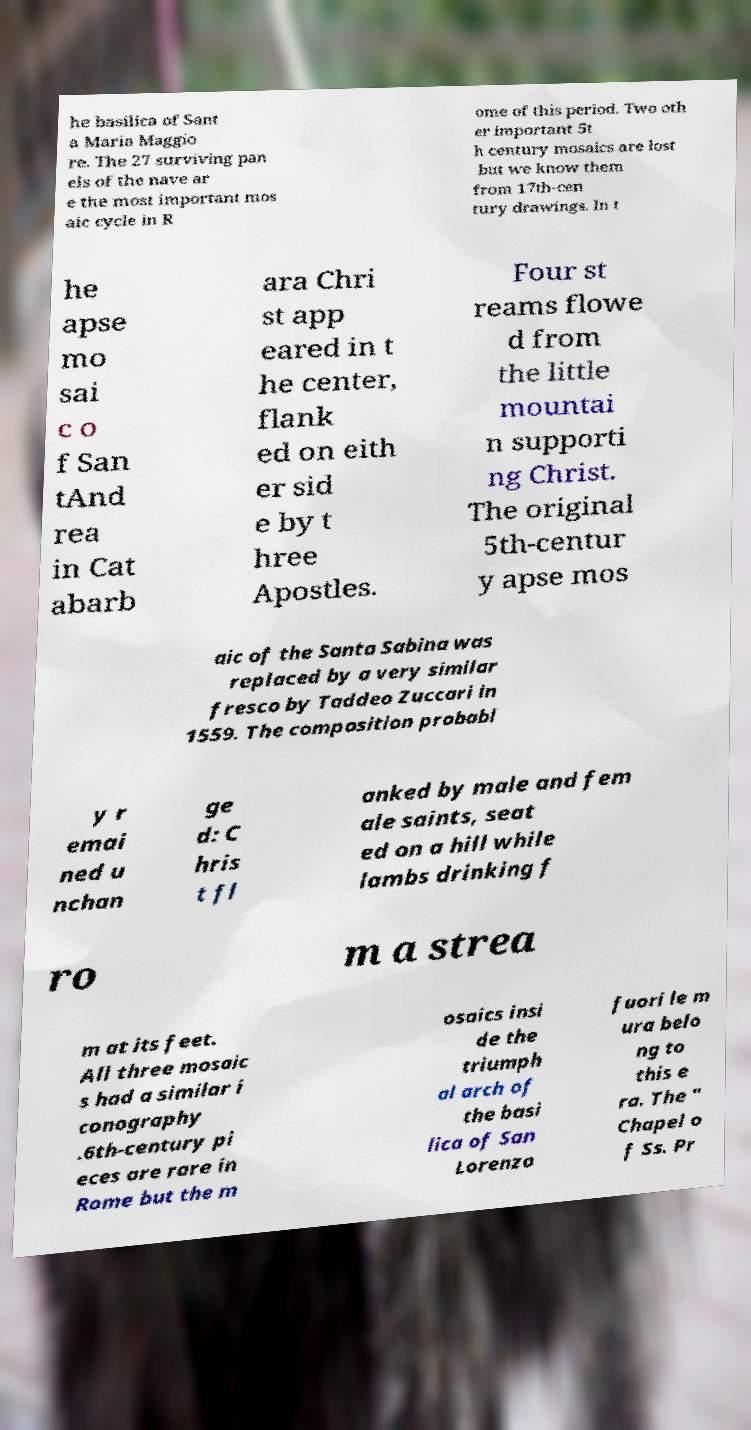Please read and relay the text visible in this image. What does it say? he basilica of Sant a Maria Maggio re. The 27 surviving pan els of the nave ar e the most important mos aic cycle in R ome of this period. Two oth er important 5t h century mosaics are lost but we know them from 17th-cen tury drawings. In t he apse mo sai c o f San tAnd rea in Cat abarb ara Chri st app eared in t he center, flank ed on eith er sid e by t hree Apostles. Four st reams flowe d from the little mountai n supporti ng Christ. The original 5th-centur y apse mos aic of the Santa Sabina was replaced by a very similar fresco by Taddeo Zuccari in 1559. The composition probabl y r emai ned u nchan ge d: C hris t fl anked by male and fem ale saints, seat ed on a hill while lambs drinking f ro m a strea m at its feet. All three mosaic s had a similar i conography .6th-century pi eces are rare in Rome but the m osaics insi de the triumph al arch of the basi lica of San Lorenzo fuori le m ura belo ng to this e ra. The " Chapel o f Ss. Pr 